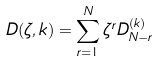<formula> <loc_0><loc_0><loc_500><loc_500>D ( \zeta , k ) = \sum _ { r = 1 } ^ { N } \zeta ^ { r } D ^ { ( k ) } _ { N - r }</formula> 